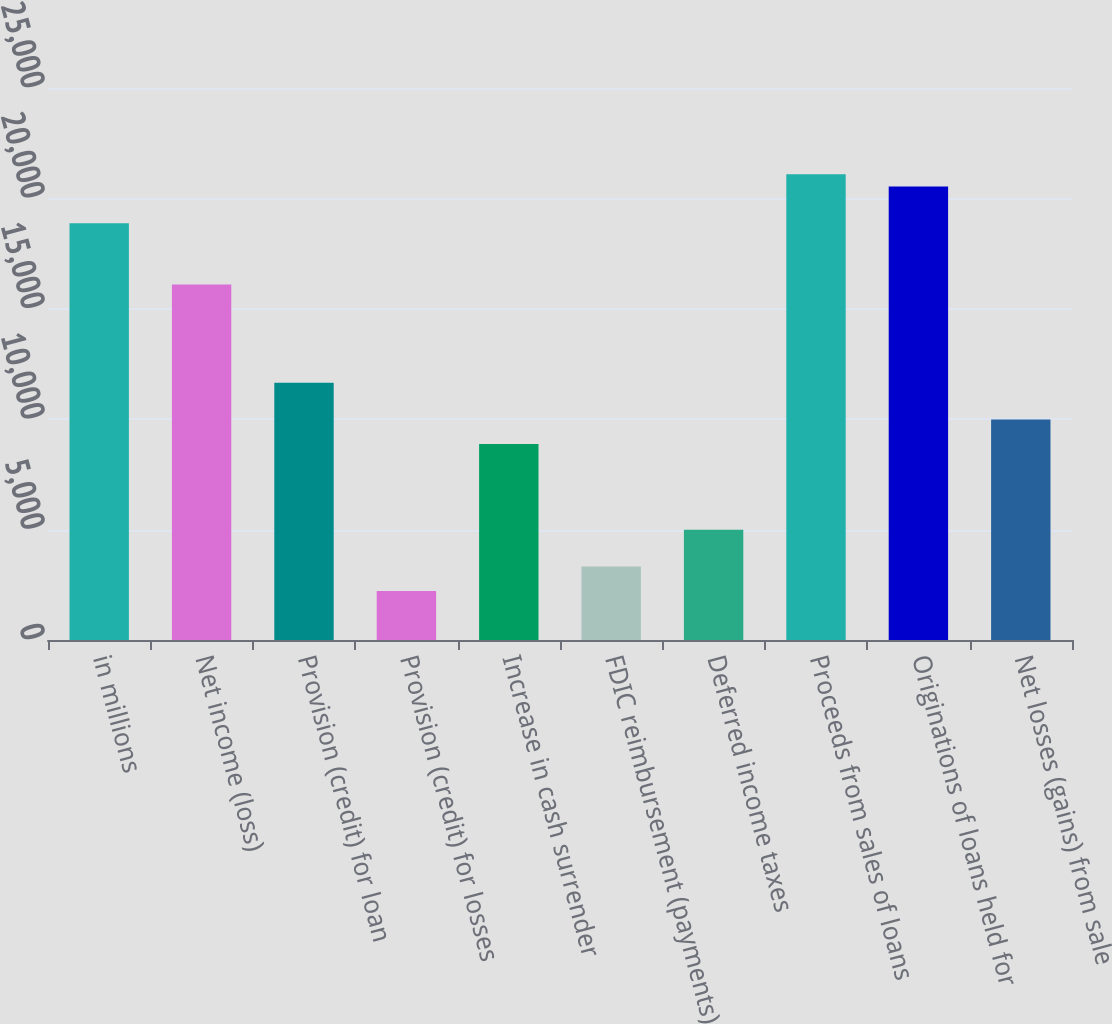Convert chart. <chart><loc_0><loc_0><loc_500><loc_500><bar_chart><fcel>in millions<fcel>Net income (loss)<fcel>Provision (credit) for loan<fcel>Provision (credit) for losses<fcel>Increase in cash surrender<fcel>FDIC reimbursement (payments)<fcel>Deferred income taxes<fcel>Proceeds from sales of loans<fcel>Originations of loans held for<fcel>Net losses (gains) from sale<nl><fcel>18871<fcel>16096<fcel>11656<fcel>2221<fcel>8881<fcel>3331<fcel>4996<fcel>21091<fcel>20536<fcel>9991<nl></chart> 